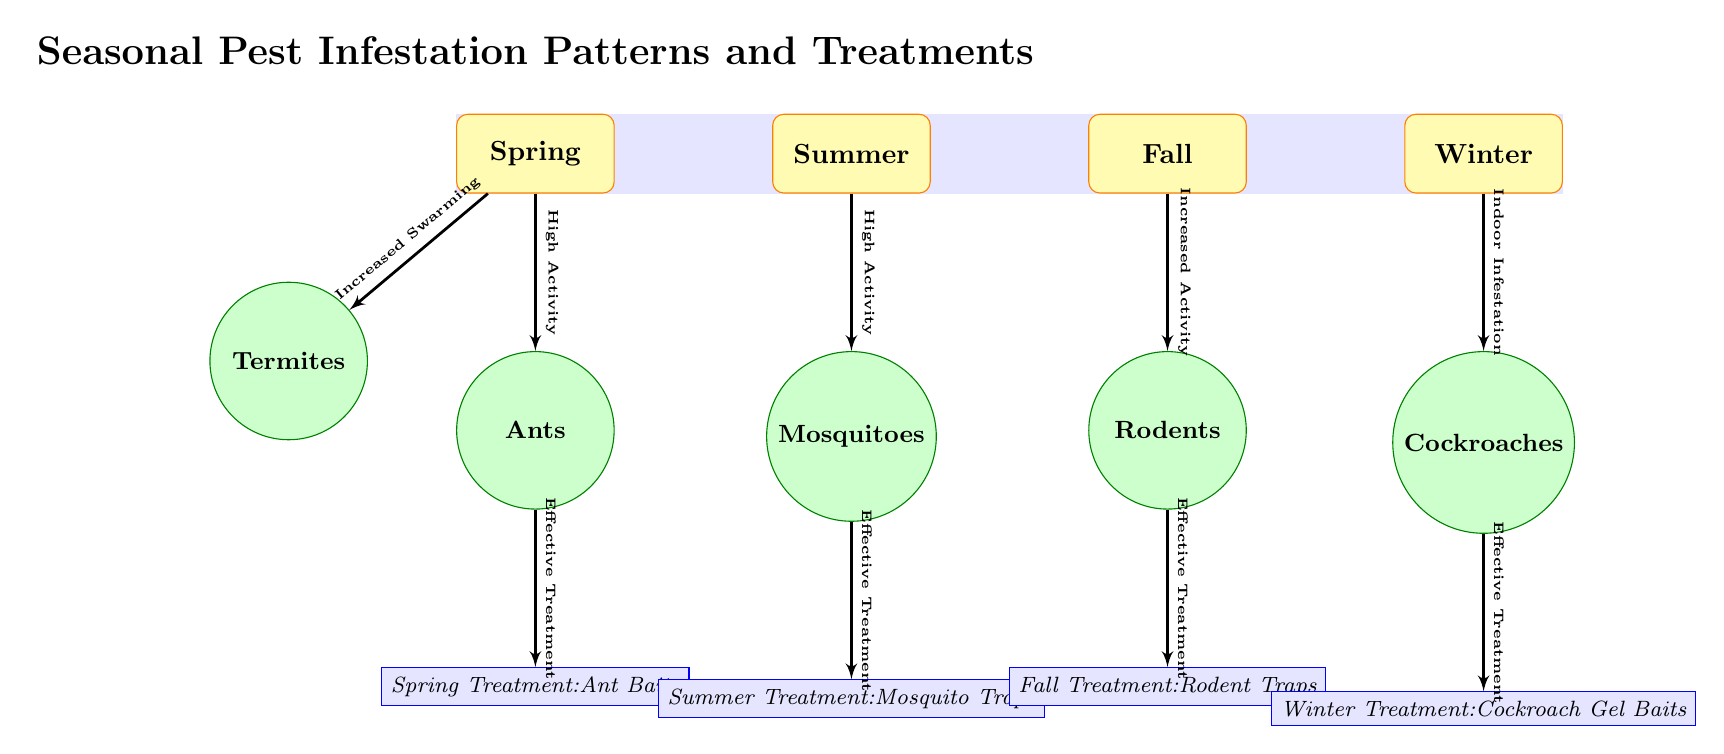What pests are associated with Spring? The diagram indicates that "Ants" and "Termites" are the pests associated with Spring as they are both listed below the Spring node.
Answer: Ants, Termites What treatment is recommended for Mosquitoes? The treatment node connected to Mosquitoes shows "Summer Treatment: Mosquito Traps," which is explicitly stated in the diagram.
Answer: Summer Treatment: Mosquito Traps Which season has the highest pest activity? The diagram indicates "High Activity" for both Spring (Ants) and Summer (Mosquitoes), suggesting these are peak seasons for pest activity.
Answer: Spring, Summer How many pests are identified in the Fall season? The diagram shows "Rodents" as the only pest associated with the Fall season, which is indicated directly beneath the Fall node.
Answer: 1 What treatment should be used for Ants based on their activity? The diagram specifies "Effective Treatment" leads to "Spring Treatment: Ant Baits," demonstrating the recommended treatment for Ants during their active season.
Answer: Spring Treatment: Ant Baits Which pest has "Indoor Infestation" noted? The diagram directly indicates that "Cockroaches" have the highest activity noted as "Indoor Infestation" in the Winter season.
Answer: Cockroaches What type of diagram is this? This is a textbook diagram, as indicated by the clarity of information depicting seasonal pest patterns and treatment methods.
Answer: Textbook Diagram Which two pests have treatments labeled in the Summer? The diagram lists "Mosquitoes" with their relevant treatment during Summer, while "Ants" have their treatment during Spring, indicating only one pest associated with Summer.
Answer: Mosquitoes What connects the Winter season to the treatment for Cockroaches? The line labeled "Effective Treatment" connects the Winter season which identifies "Indoor Infestation" associated with Cockroaches to their specific treatment node.
Answer: Effective Treatment 